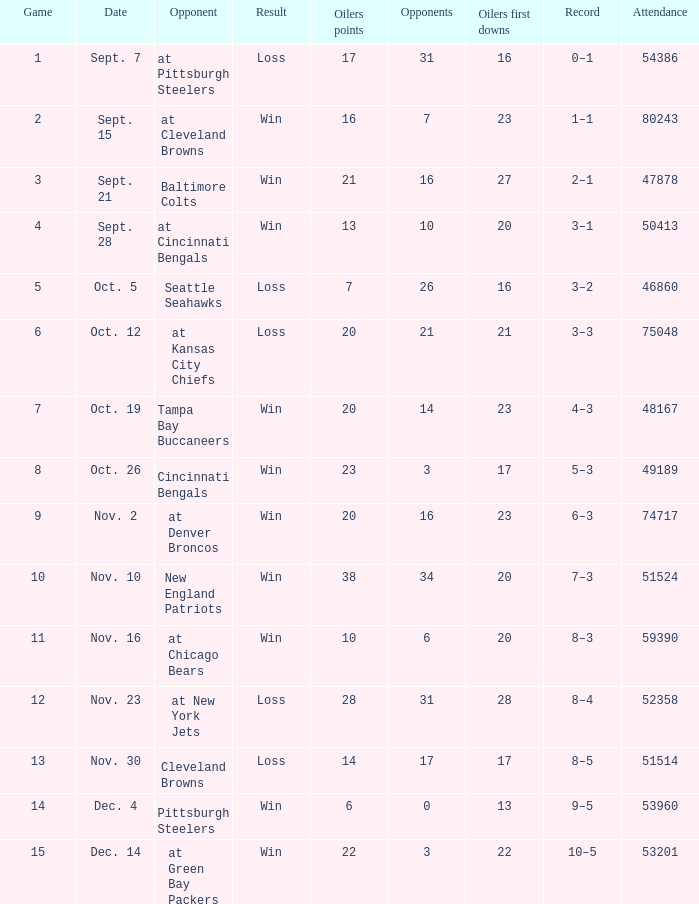What was the total opponents points for the game were the Oilers scored 21? 16.0. 